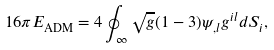Convert formula to latex. <formula><loc_0><loc_0><loc_500><loc_500>1 6 \pi E _ { \text {ADM} } = 4 \oint _ { \infty } \sqrt { g } ( 1 - 3 ) \psi _ { , l } g ^ { i l } d S _ { i } ,</formula> 